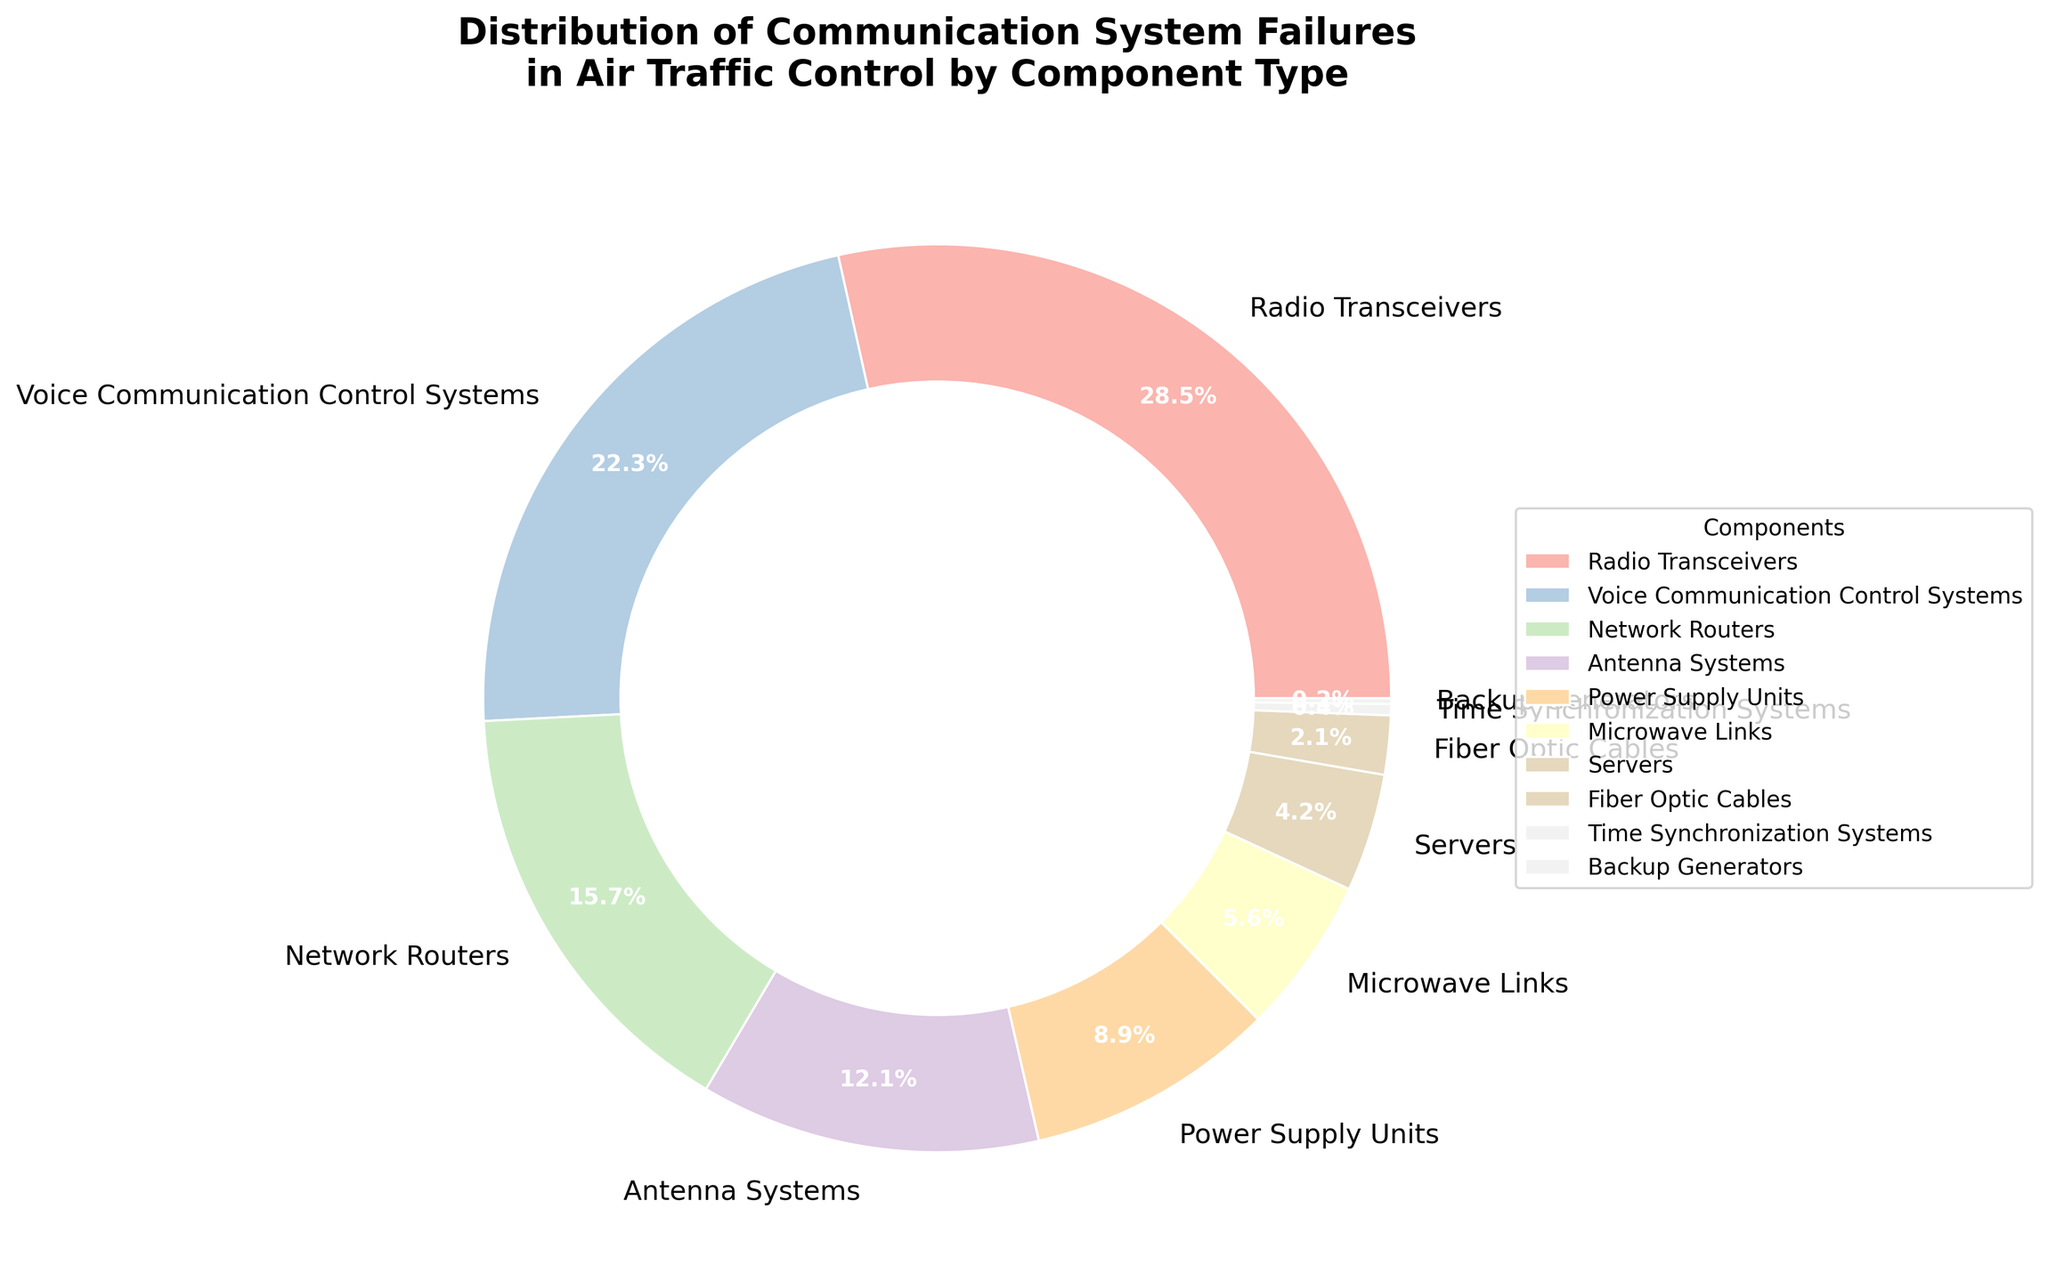Which component has the highest percentage of communication system failures? By looking at the pie chart, we can see that the component with the largest slice represents the highest percentage. In this case, it is "Radio Transceivers" with 28.5%.
Answer: Radio Transceivers What is the combined percentage of failures for Network Routers and Servers? To find the combined percentage, add the percentages for Network Routers and Servers. Network Routers: 15.7%, Servers: 4.2%, so combined: 15.7 + 4.2 = 19.9%.
Answer: 19.9% Which component type has a smaller failure percentage: Antenna Systems or Power Supply Units? By viewing the pie chart, check the percentages for Antenna Systems and Power Supply Units. Antenna Systems: 12.1%, Power Supply Units: 8.9%. Since 8.9% is smaller, answer is Power Supply Units.
Answer: Power Supply Units How much greater is the failure percentage of Radio Transceivers compared to Fiber Optic Cables? Subtract the percentage of Fiber Optic Cables from that of Radio Transceivers. Radio Transceivers: 28.5%, Fiber Optic Cables: 2.1%. Difference: 28.5 - 2.1 = 26.4%.
Answer: 26.4% What percentage of the failures is accounted for by components that have a percentage less than 5%? Add the percentages of components with less than 5%: Servers (4.2%), Fiber Optic Cables (2.1%), Time Synchronization Systems (0.4%), Backup Generators (0.2%). Total: 4.2 + 2.1 + 0.4 + 0.2 = 6.9%.
Answer: 6.9% Are Voice Communication Control Systems responsible for more or fewer failures than Network Routers? Compare the percentages: Voice Communication Control Systems (22.3%) and Network Routers (15.7%). Since 22.3% is greater than 15.7%, Voice Communication Control Systems have more failures.
Answer: More How does the failure percentage of Microwave Links compare to that of Power Supply Units visually? By examining the pie chart, we can see that the slice for Microwave Links is smaller than that for Power Supply Units. Microwave Links: 5.6%, Power Supply Units: 8.9%.
Answer: Smaller Which component type shows the lowest percentage of failures? From the pie chart, the smallest slice represents the component with the lowest percentage of failures, which is "Backup Generators" with 0.2%.
Answer: Backup Generators What is the average failure percentage of the top three components? Add the percentages of the top three components and divide by 3. Radio Transceivers (28.5%) + Voice Communication Control Systems (22.3%) + Network Routers (15.7%), Total: 66.5%, Average: 66.5 / 3 = 22.17%.
Answer: 22.17% How many components have a failure percentage greater than 10%? Identify the components with percentages greater than 10%: Radio Transceivers (28.5%), Voice Communication Control Systems (22.3%), Network Routers (15.7%), and Antenna Systems (12.1%). There are 4 such components.
Answer: 4 